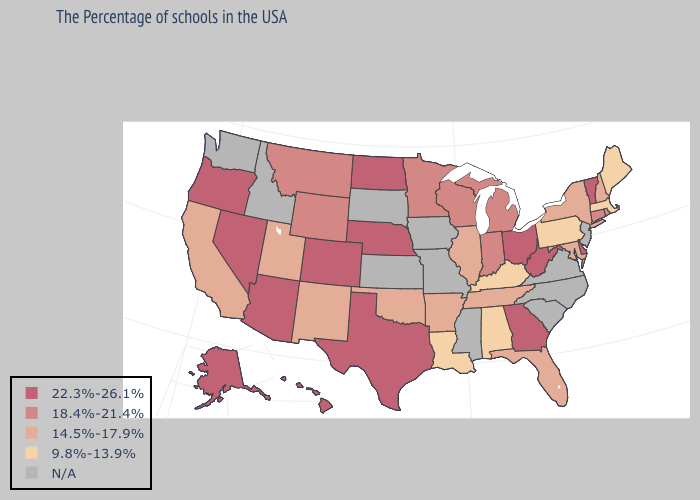Is the legend a continuous bar?
Answer briefly. No. What is the value of Idaho?
Concise answer only. N/A. Among the states that border North Dakota , which have the highest value?
Be succinct. Minnesota, Montana. Which states have the highest value in the USA?
Keep it brief. Vermont, Delaware, West Virginia, Ohio, Georgia, Nebraska, Texas, North Dakota, Colorado, Arizona, Nevada, Oregon, Alaska, Hawaii. Name the states that have a value in the range 22.3%-26.1%?
Concise answer only. Vermont, Delaware, West Virginia, Ohio, Georgia, Nebraska, Texas, North Dakota, Colorado, Arizona, Nevada, Oregon, Alaska, Hawaii. Name the states that have a value in the range 14.5%-17.9%?
Write a very short answer. New Hampshire, New York, Maryland, Florida, Tennessee, Illinois, Arkansas, Oklahoma, New Mexico, Utah, California. What is the highest value in the USA?
Short answer required. 22.3%-26.1%. What is the lowest value in states that border Oregon?
Short answer required. 14.5%-17.9%. Does the first symbol in the legend represent the smallest category?
Answer briefly. No. Does the first symbol in the legend represent the smallest category?
Quick response, please. No. What is the value of New Mexico?
Short answer required. 14.5%-17.9%. Name the states that have a value in the range 9.8%-13.9%?
Quick response, please. Maine, Massachusetts, Pennsylvania, Kentucky, Alabama, Louisiana. Among the states that border Montana , does North Dakota have the highest value?
Write a very short answer. Yes. 